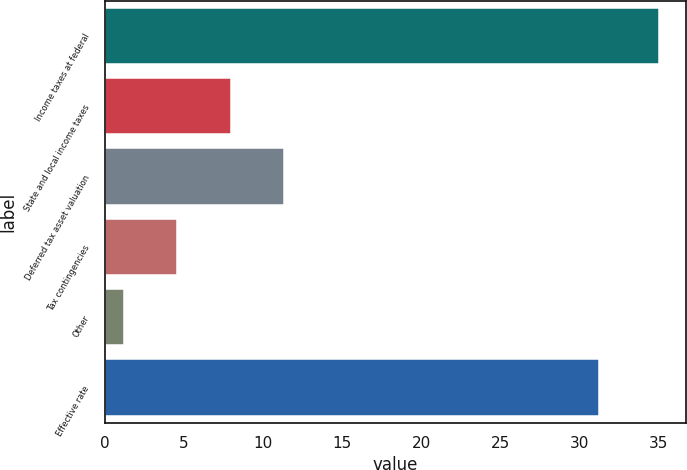Convert chart to OTSL. <chart><loc_0><loc_0><loc_500><loc_500><bar_chart><fcel>Income taxes at federal<fcel>State and local income taxes<fcel>Deferred tax asset valuation<fcel>Tax contingencies<fcel>Other<fcel>Effective rate<nl><fcel>35<fcel>7.96<fcel>11.34<fcel>4.58<fcel>1.2<fcel>31.2<nl></chart> 